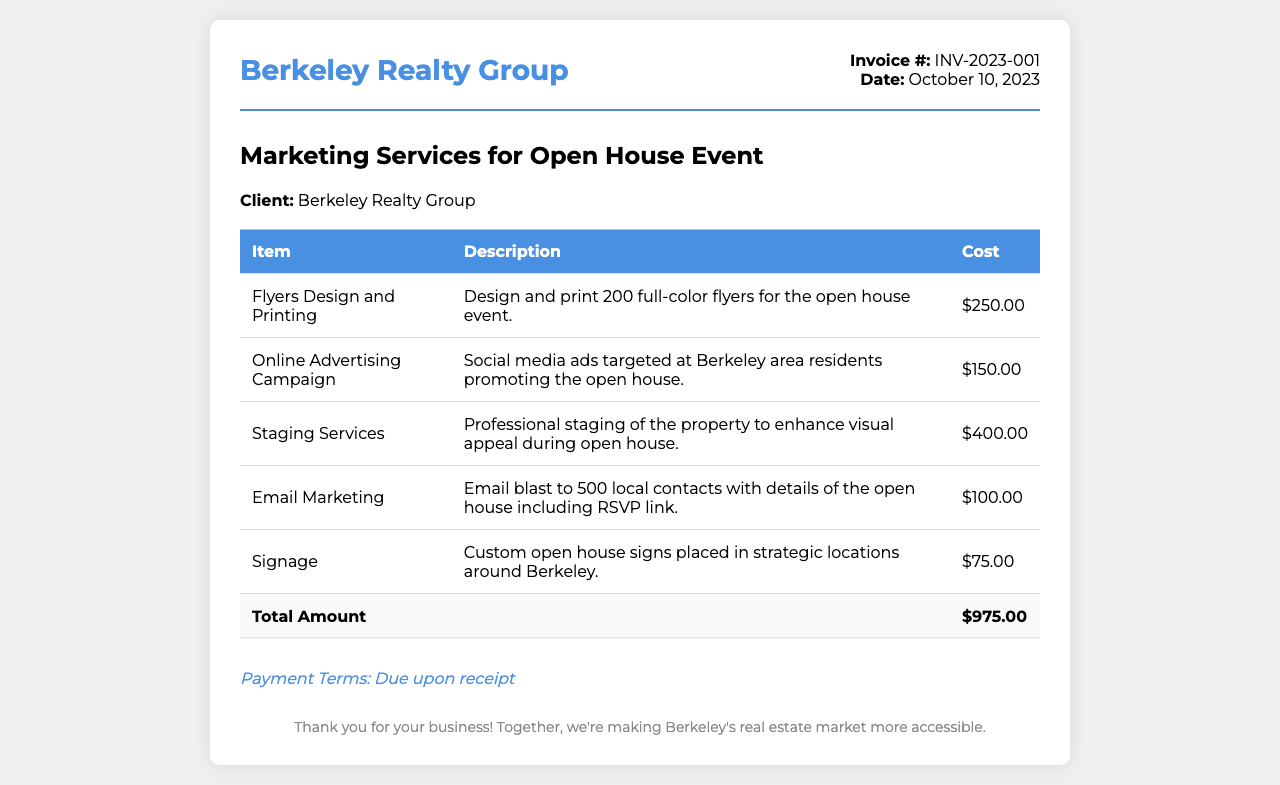What is the invoice number? The invoice number is indicated at the top right corner of the document.
Answer: INV-2023-001 What date was the invoice issued? The date is shown next to the invoice number at the top right corner.
Answer: October 10, 2023 What is the total amount due? The total amount is listed at the bottom of the itemized table as "Total Amount".
Answer: $975.00 How many flyers were designed and printed? The number of flyers is mentioned in the description of the first item in the table.
Answer: 200 What service cost the most? The costs are itemized, and we can determine the highest cost from the table.
Answer: Staging Services What type of advertising was included? The type of advertising can be found in the description of one of the items in the table.
Answer: Online Advertising Campaign What is the payment term mentioned in the invoice? The payment terms are noted at the bottom of the invoice after the cost summary.
Answer: Due upon receipt What item includes email marketing? The item related to email marketing can be directly identified from the table provided.
Answer: Email Marketing How much was spent on signage? The amount spent on signage is stated in the last item of the cost table.
Answer: $75.00 